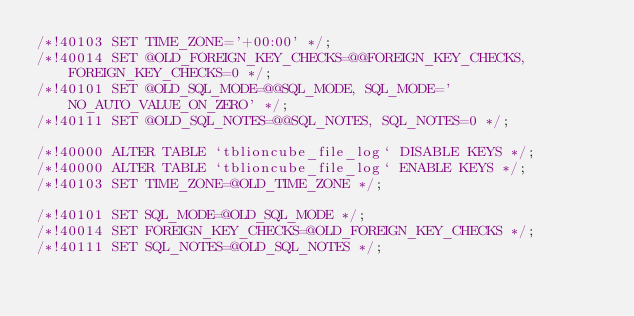Convert code to text. <code><loc_0><loc_0><loc_500><loc_500><_SQL_>/*!40103 SET TIME_ZONE='+00:00' */;
/*!40014 SET @OLD_FOREIGN_KEY_CHECKS=@@FOREIGN_KEY_CHECKS, FOREIGN_KEY_CHECKS=0 */;
/*!40101 SET @OLD_SQL_MODE=@@SQL_MODE, SQL_MODE='NO_AUTO_VALUE_ON_ZERO' */;
/*!40111 SET @OLD_SQL_NOTES=@@SQL_NOTES, SQL_NOTES=0 */;

/*!40000 ALTER TABLE `tblioncube_file_log` DISABLE KEYS */;
/*!40000 ALTER TABLE `tblioncube_file_log` ENABLE KEYS */;
/*!40103 SET TIME_ZONE=@OLD_TIME_ZONE */;

/*!40101 SET SQL_MODE=@OLD_SQL_MODE */;
/*!40014 SET FOREIGN_KEY_CHECKS=@OLD_FOREIGN_KEY_CHECKS */;
/*!40111 SET SQL_NOTES=@OLD_SQL_NOTES */;

</code> 